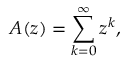<formula> <loc_0><loc_0><loc_500><loc_500>A ( z ) = \sum _ { k = 0 } ^ { \infty } z ^ { k } ,</formula> 